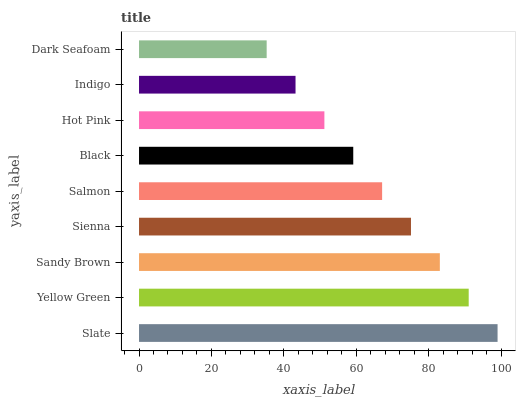Is Dark Seafoam the minimum?
Answer yes or no. Yes. Is Slate the maximum?
Answer yes or no. Yes. Is Yellow Green the minimum?
Answer yes or no. No. Is Yellow Green the maximum?
Answer yes or no. No. Is Slate greater than Yellow Green?
Answer yes or no. Yes. Is Yellow Green less than Slate?
Answer yes or no. Yes. Is Yellow Green greater than Slate?
Answer yes or no. No. Is Slate less than Yellow Green?
Answer yes or no. No. Is Salmon the high median?
Answer yes or no. Yes. Is Salmon the low median?
Answer yes or no. Yes. Is Sandy Brown the high median?
Answer yes or no. No. Is Black the low median?
Answer yes or no. No. 